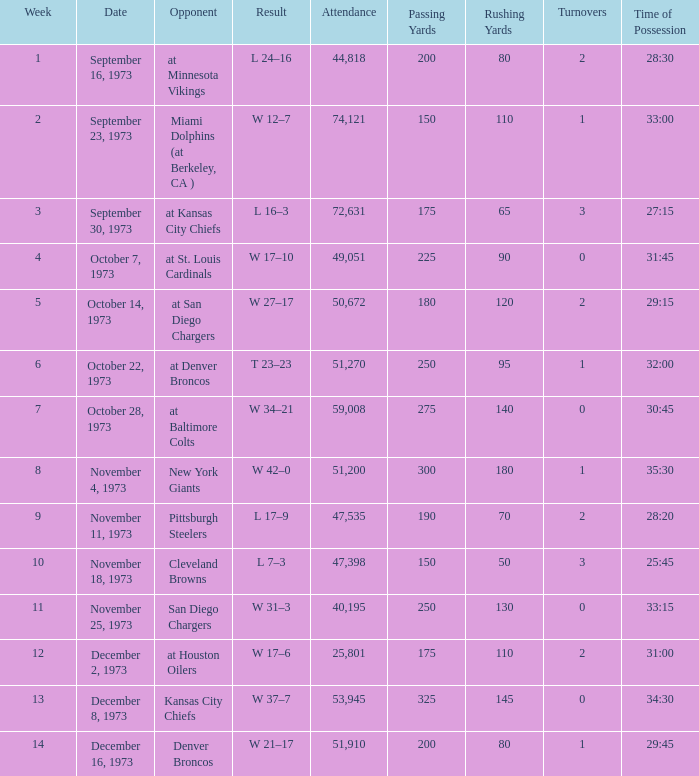What was the crowd size at the game against the kansas city chiefs earlier than week 13? None. 